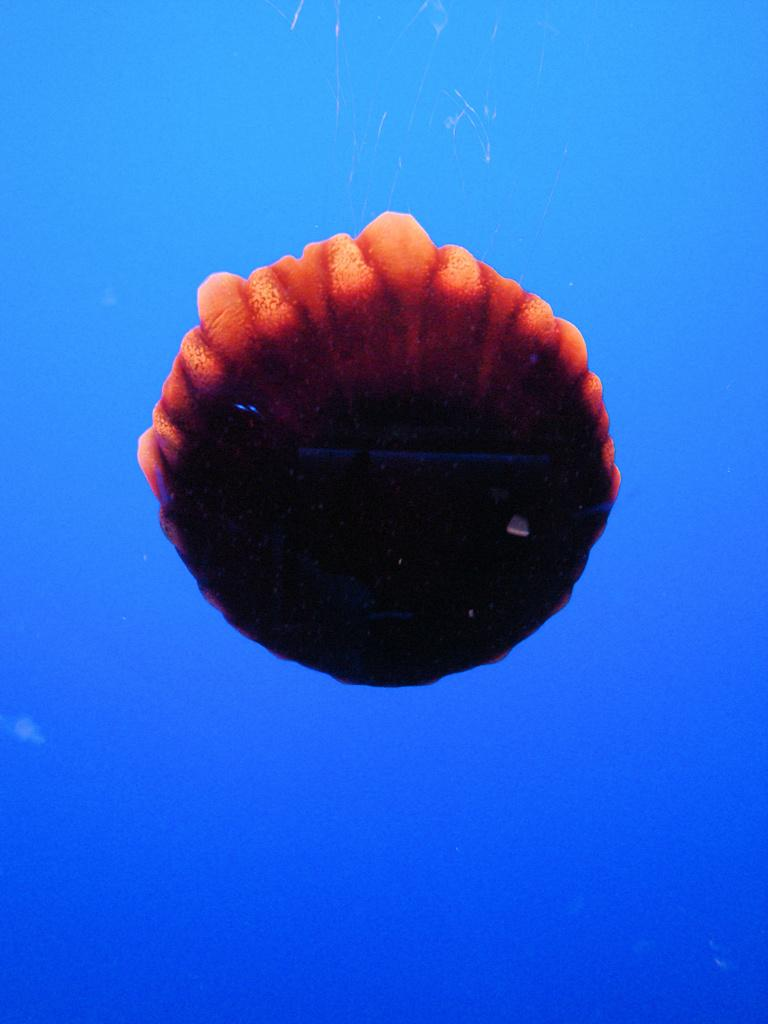What is the main subject of the image? The main subject of the image is a hot air balloon. Where is the hot air balloon located in the image? The hot air balloon is in the sky. What type of steam is being produced by the bit in the image? There is no bit or steam present in the image; it features a hot air balloon in the sky. 